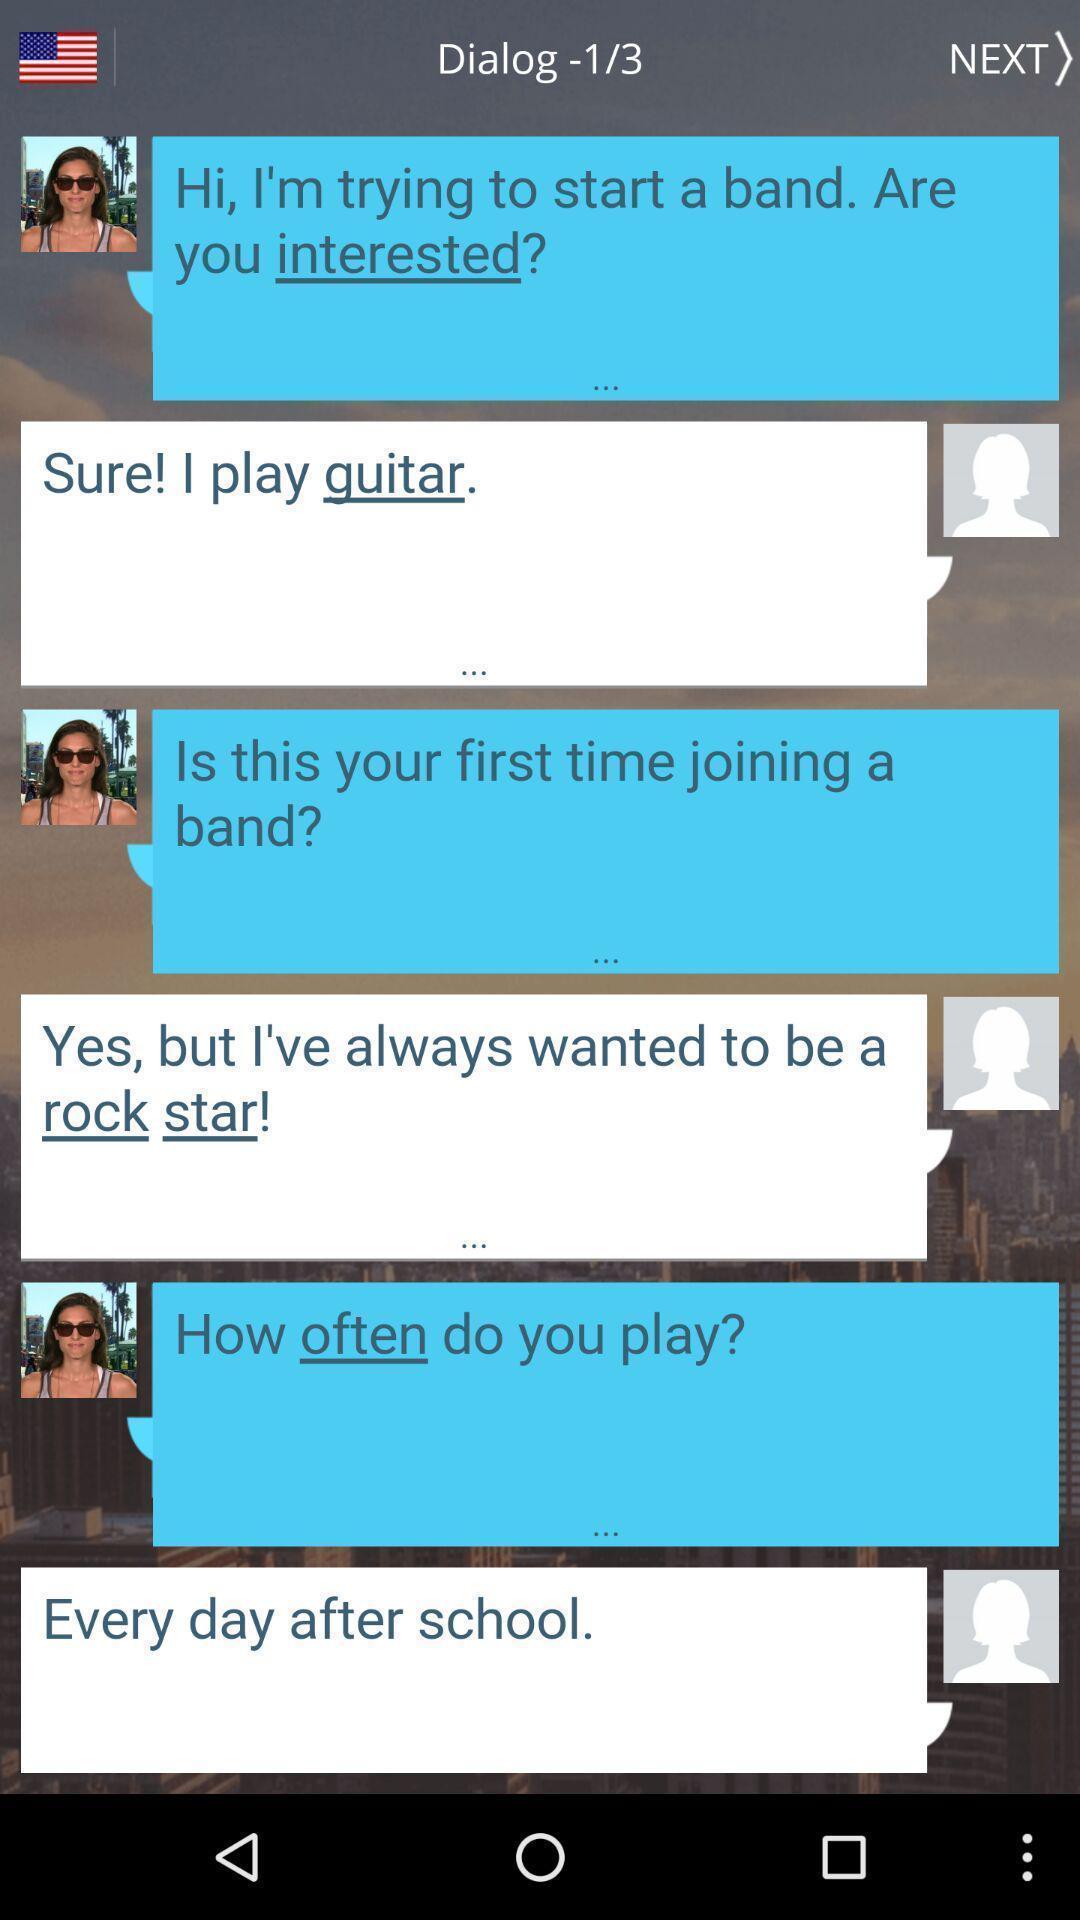Tell me what you see in this picture. Screen showing a chat page. 